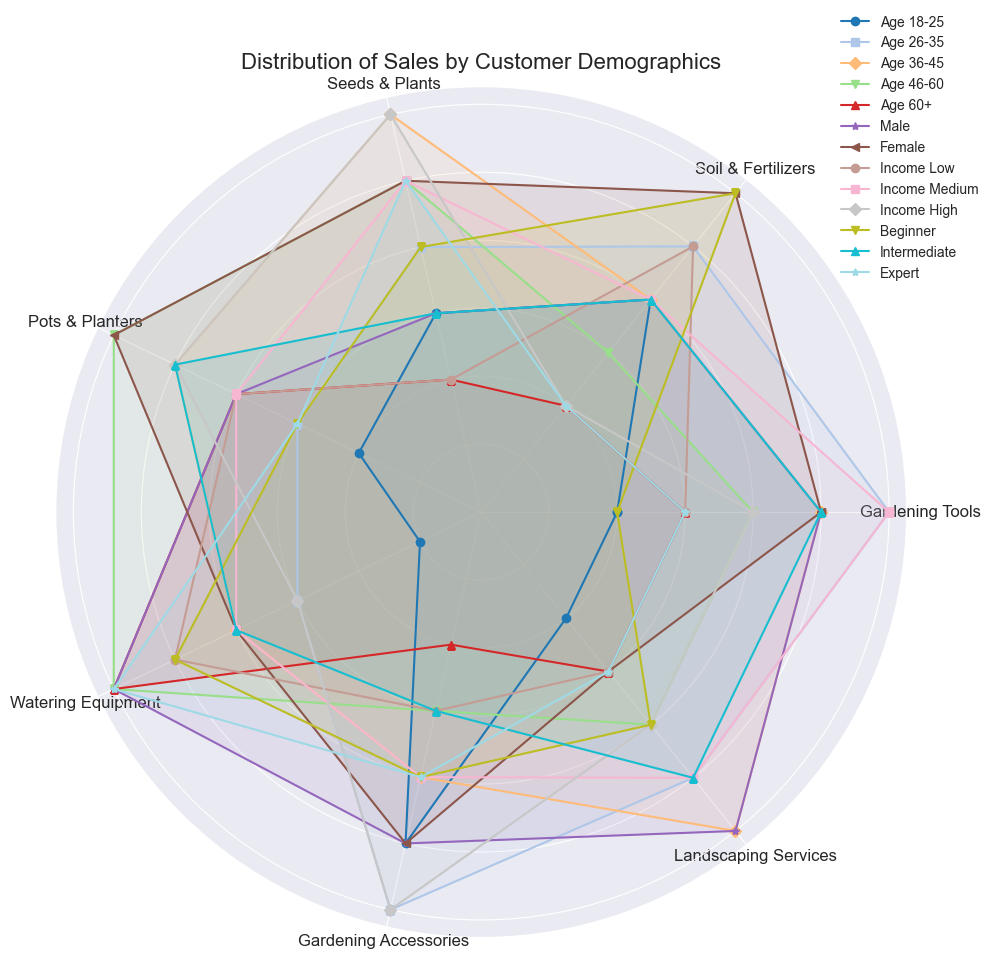What is the total sales distribution for Gardening Tools across all age groups? To find the total sales distribution for Gardening Tools across all age groups, sum the values provided for each age group: 10 (Age 18-25) + 30 (Age 26-35) + 25 (Age 36-45) + 20 (Age 46-60) + 15 (Age 60+). This gives: 10 + 30 + 25 + 20 + 15 = 100.
Answer: 100 Which customer demographic has the highest sales for Seeds & Plants? Check the values for Seeds & Plants across all customer demographics and identify the highest. Values are: Age 36-45 (30) which is higher than the other values in Age Group (15, 20, 25, 10) and higher than any value in other demographics (10, 25, 10, 25, 30, 20, 15, 25). Therefore, the age group 36-45 has the highest sales for Seeds & Plants.
Answer: Age 36-45 What is the average sales distribution for Watering Equipment across Gender categories? To find the average sales distribution for Watering Equipment across Male and Female, sum the values for both genders and divide by the number of categories: 30 (Male) + 20 (Female) = 50. Then, divide 50 by 2, resulting in 50 / 2 = 25.
Answer: 25 Which product category has the most similar sales distribution between Income Medium and Income High? Compare the sales values across different product categories between Income Medium and Income High. Gardening Tools (30, 20), Soil & Fertilizers (20, 10), Seeds & Plants (25, 30), Pots & Planters (20, 25), Watering Equipment (20, 15), Gardening Accessories (20, 30), Landscaping Services (25, 20). The smallest difference is between Landscaping Services with values 25 (Income Medium) and 20 (Income High).
Answer: Landscaping Services How does the sales distribution for Gardening Accessories differ between customers with Beginner and Expert gardening experience? Check the values for Gardening Accessories: Beginners (20 units) and Experts (20 units). The distribution is the same with both categories having 20 units each.
Answer: No difference Which age group has the lowest sales for Landscaping Services and how much are the sales? Check Landscaping Services sales across age groups: 18-25 (10), 26-35 (25), 36-45 (30), 46-60 (20), 60+ (15). The lowest sales are in the age group 18-25 with 10 units.
Answer: Age 18-25 with 10 units What is the combined sales total for Soil & Fertilizers and Pots & Planters among Female customers? Sum the sales values for Soil & Fertilizers and Pots & Planters for Female customers: 30 (Soil & Fertilizers) + 30 (Pots & Planters). This gives a total of: 30 + 30 = 60.
Answer: 60 How does the sales distribution for Seeds & Plants compare between income levels (Low, Medium, and High)? Check the sales values for Seeds & Plants across the income levels: Income Low (10), Income Medium (25), and Income High (30). The sales are increasing across these income levels: Income Low < Income Medium < Income High.
Answer: Increasing Which product category shows the highest sales for customers with Intermediate gardening experience? Look for the highest value in Intermediate gardening experience: Gardening Tools (25), Soil & Fertilizers (20), Seeds & Plants (15), Pots & Planters (25), Watering Equipment (20), Gardening Accessories (15), Landscaping Services (25). Three categories (Gardening Tools, Pots & Planters, and Landscaping Services) all have the highest value of 25 units.
Answer: Gardening Tools, Pots & Planters, Landscaping Services 